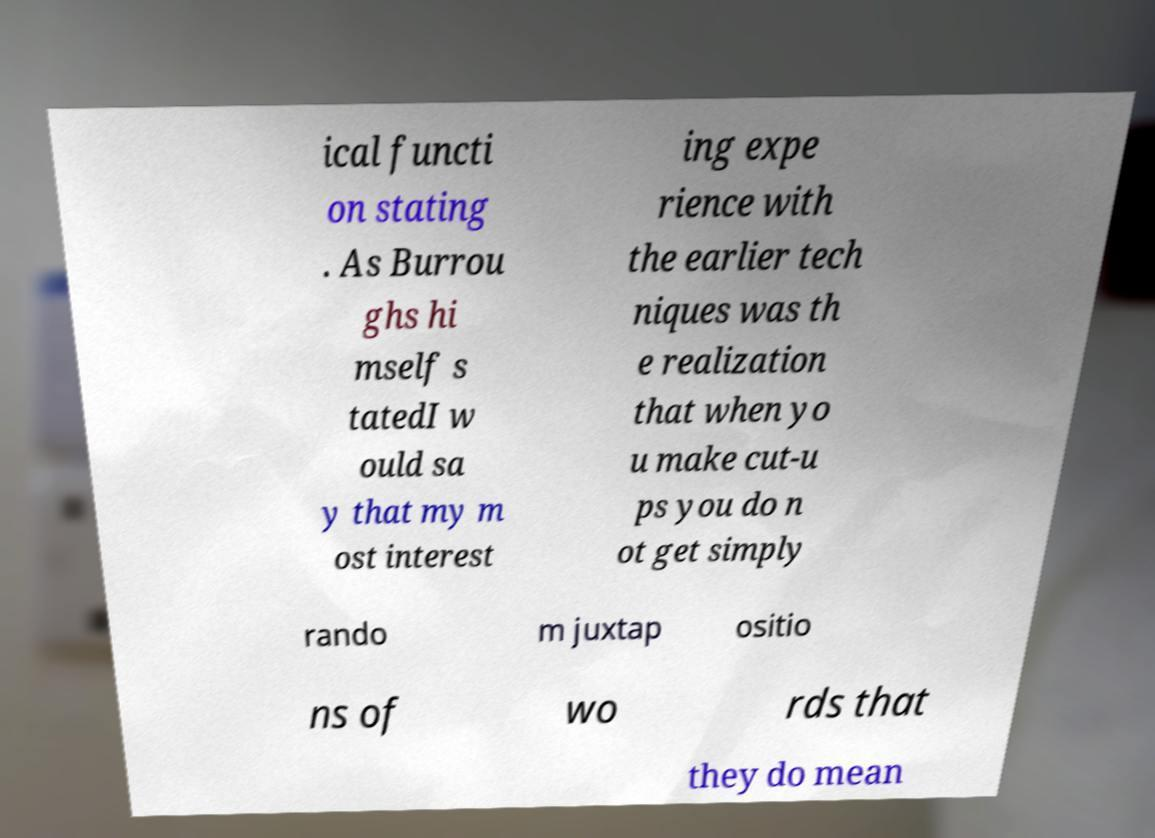Could you assist in decoding the text presented in this image and type it out clearly? ical functi on stating . As Burrou ghs hi mself s tatedI w ould sa y that my m ost interest ing expe rience with the earlier tech niques was th e realization that when yo u make cut-u ps you do n ot get simply rando m juxtap ositio ns of wo rds that they do mean 